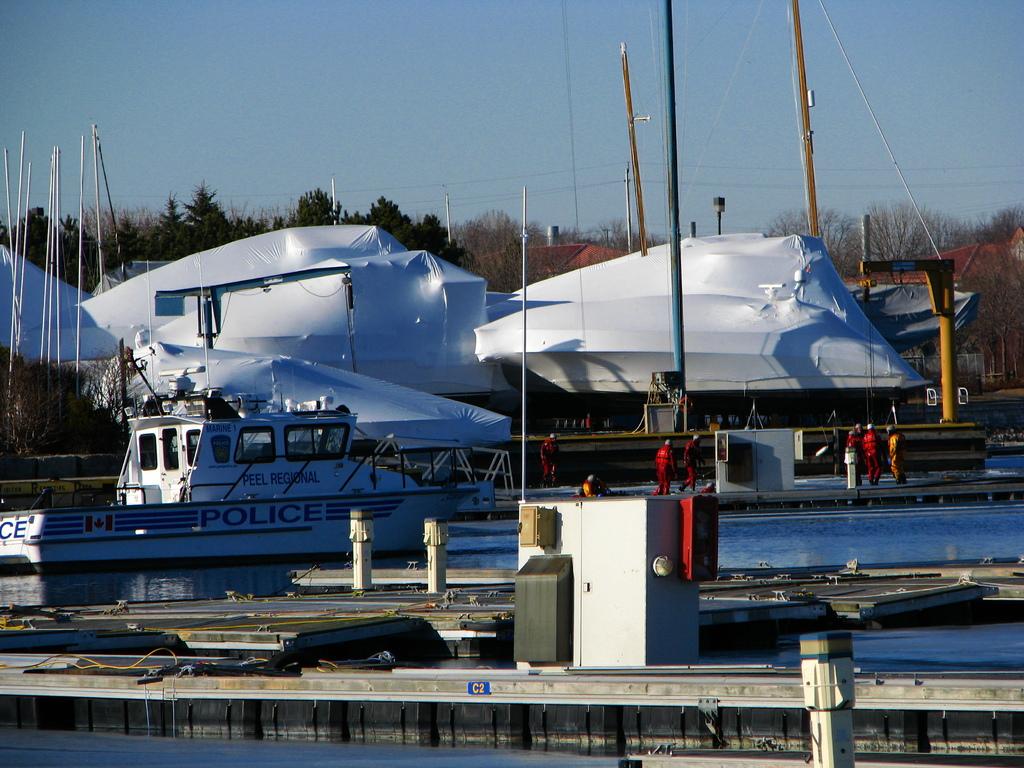Which sector of the government does the small boat in the water belong to?
Keep it short and to the point. Police. What is the first word written above the word "police"?
Your answer should be compact. Peel. 